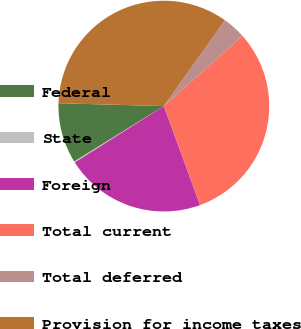Convert chart. <chart><loc_0><loc_0><loc_500><loc_500><pie_chart><fcel>Federal<fcel>State<fcel>Foreign<fcel>Total current<fcel>Total deferred<fcel>Provision for income taxes<nl><fcel>9.25%<fcel>0.17%<fcel>21.6%<fcel>31.01%<fcel>3.56%<fcel>34.41%<nl></chart> 